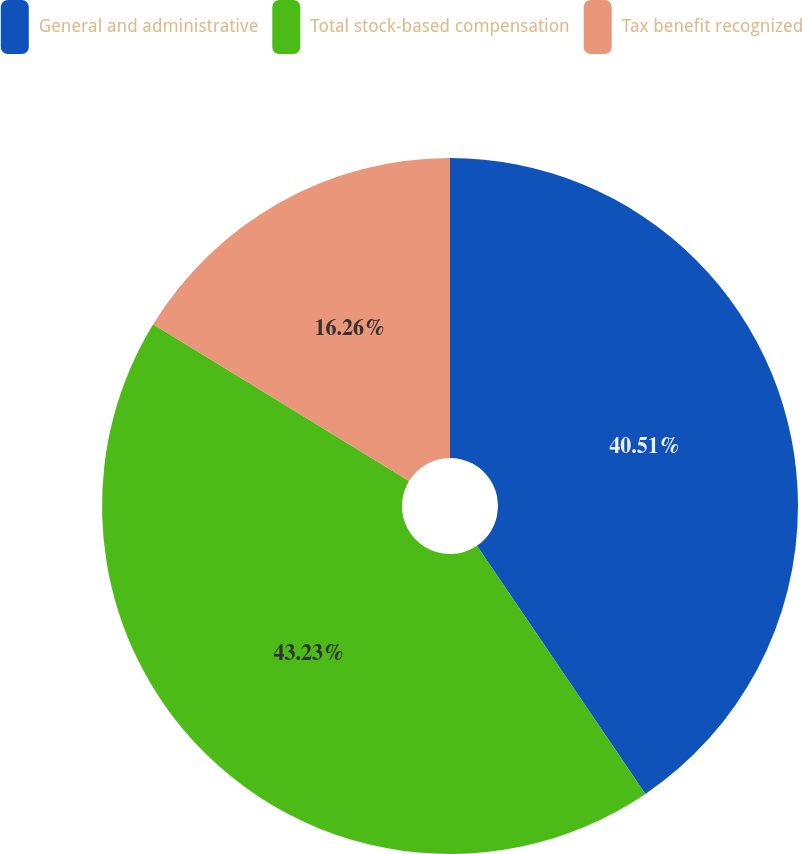<chart> <loc_0><loc_0><loc_500><loc_500><pie_chart><fcel>General and administrative<fcel>Total stock-based compensation<fcel>Tax benefit recognized<nl><fcel>40.51%<fcel>43.23%<fcel>16.26%<nl></chart> 